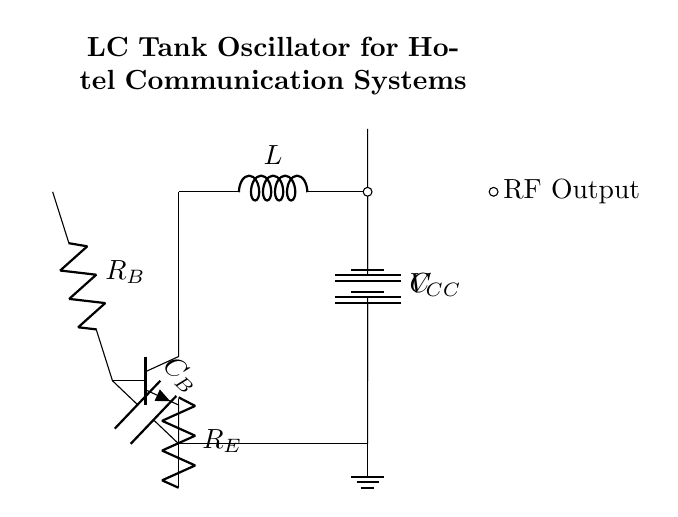What is the value of the inductor? The inductor is labeled as "L" in the circuit diagram, which denotes its value but does not specify a numerical value.
Answer: L What type of transistor is used in the circuit? The circuit diagram shows an "npn" transistor, indicating its type. This can be seen from the label on the transistor symbol in the diagram.
Answer: npn What component is connected directly to the collector of the transistor? The collector of the npn transistor is connected directly to the junction of the inductor and the capacitor, showing that it is part of the LC tank circuit.
Answer: Inductor and capacitor How many resistors are present in the circuit? There are two resistors labeled R sub B and R sub E, which can be counted visually from the circuit diagram.
Answer: 2 What is the function of the capacitor labeled C sub B? The capacitor C sub B is part of the biasing network for the base of the transistor, allowing for AC coupling while blocking DC levels. This function is inferred from its position in the circuit.
Answer: Biasing What is the purpose of the LC tank circuit? The LC tank circuit is designed to resonate at a particular frequency, allowing for the generation of radio frequencies necessary for communication systems. This is the fundamental function of such a circuit rather than any specific component.
Answer: Generate radio frequencies What is the voltage supply connected to the circuit? The voltage supply in the circuit is labeled as V sub CC, indicating the power source connected across the circuit. The diagram shows a battery symbol, which identifies the voltage source.
Answer: V sub CC 